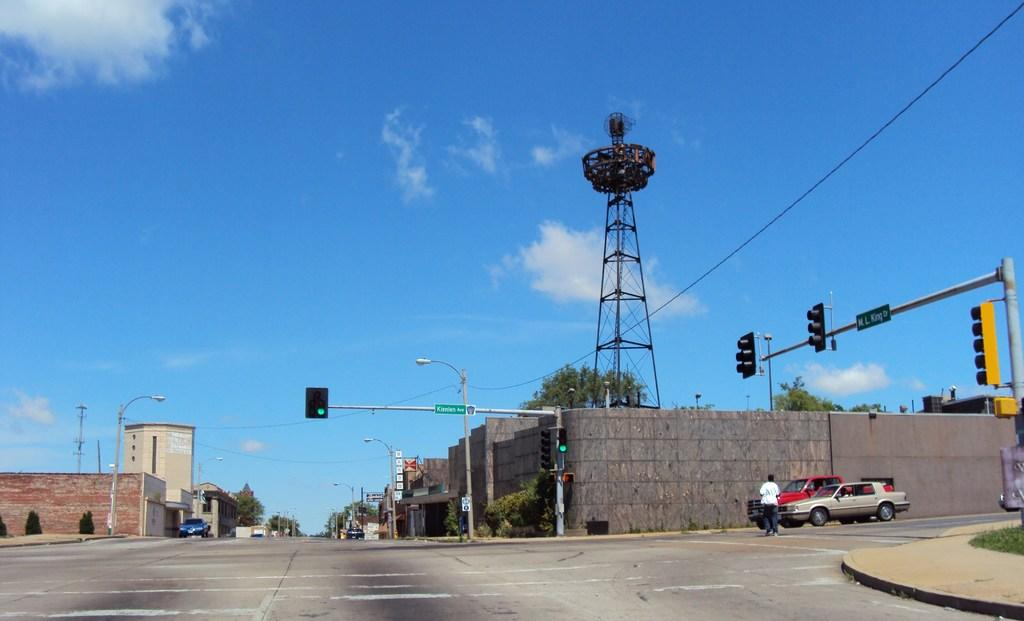What can be seen in the sky in the image? The sky with clouds is visible in the image. What type of structure is present in the image? There is a tower in the image. What are some objects related to traffic management in the image? Traffic poles, traffic signals, and street poles are present in the image. What type of lighting is present in the image? Street lights are present in the image. What type of buildings can be seen in the image? Buildings are visible in the image. What type of signage is present in the image? Sign boards are in the image. What type of transportation is present in the image? Motor vehicles are present in the image. Are there any people visible in the image? Persons are on the road in the image. What type of vegetation is visible in the image? Grass is visible in the image. Where are the tomatoes growing in the image? There are no tomatoes present in the image. What type of muscle is visible in the image? There is no muscle visible in the image. What type of library can be seen in the image? There is no library present in the image. 